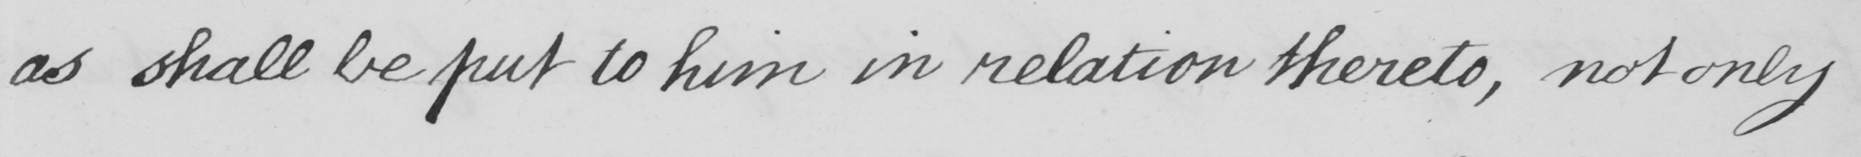What does this handwritten line say? as shall be put to him in relation thereto , not only 